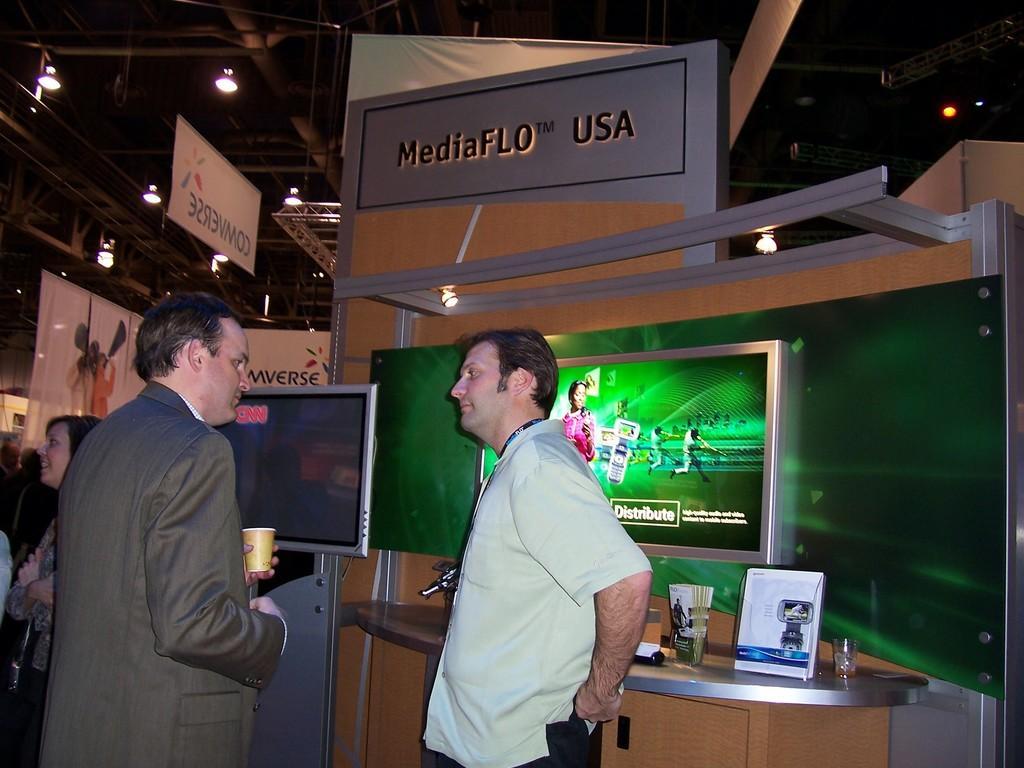Could you give a brief overview of what you see in this image? In this image in the foreground there are two persons standing, and one person is holding a cup. In the background there are televisions and some persons are standing and some boards, on the boards there is text and at the bottom there is one table. On the table there is a glass, photo frame and some objects and at the top there is ceiling and some lights. 